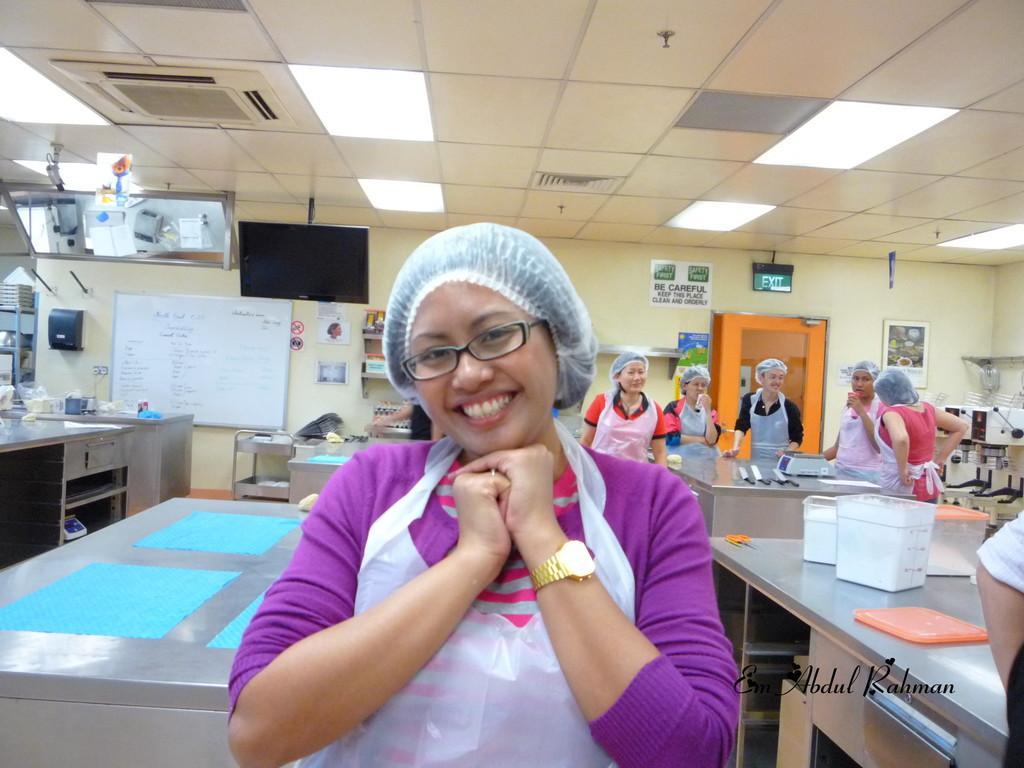Please provide a concise description of this image. At the top we can see ceiling and lights. We can see poster, calendar over a wall and also white board. Here we can see television. This is a door. This is exit board. We can see persons standing near to the table and on the table we can see boxes. 